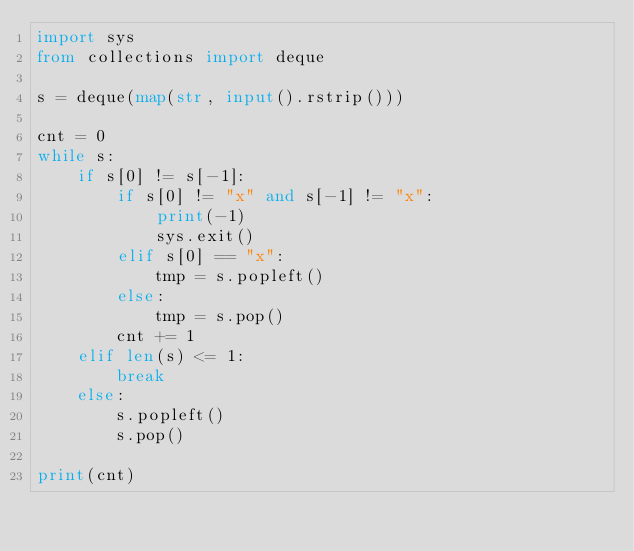<code> <loc_0><loc_0><loc_500><loc_500><_Python_>import sys
from collections import deque

s = deque(map(str, input().rstrip()))

cnt = 0
while s:
    if s[0] != s[-1]:
        if s[0] != "x" and s[-1] != "x":
            print(-1)
            sys.exit()
        elif s[0] == "x":
            tmp = s.popleft()
        else:
            tmp = s.pop()
        cnt += 1
    elif len(s) <= 1:
        break
    else:
        s.popleft()
        s.pop()

print(cnt)</code> 